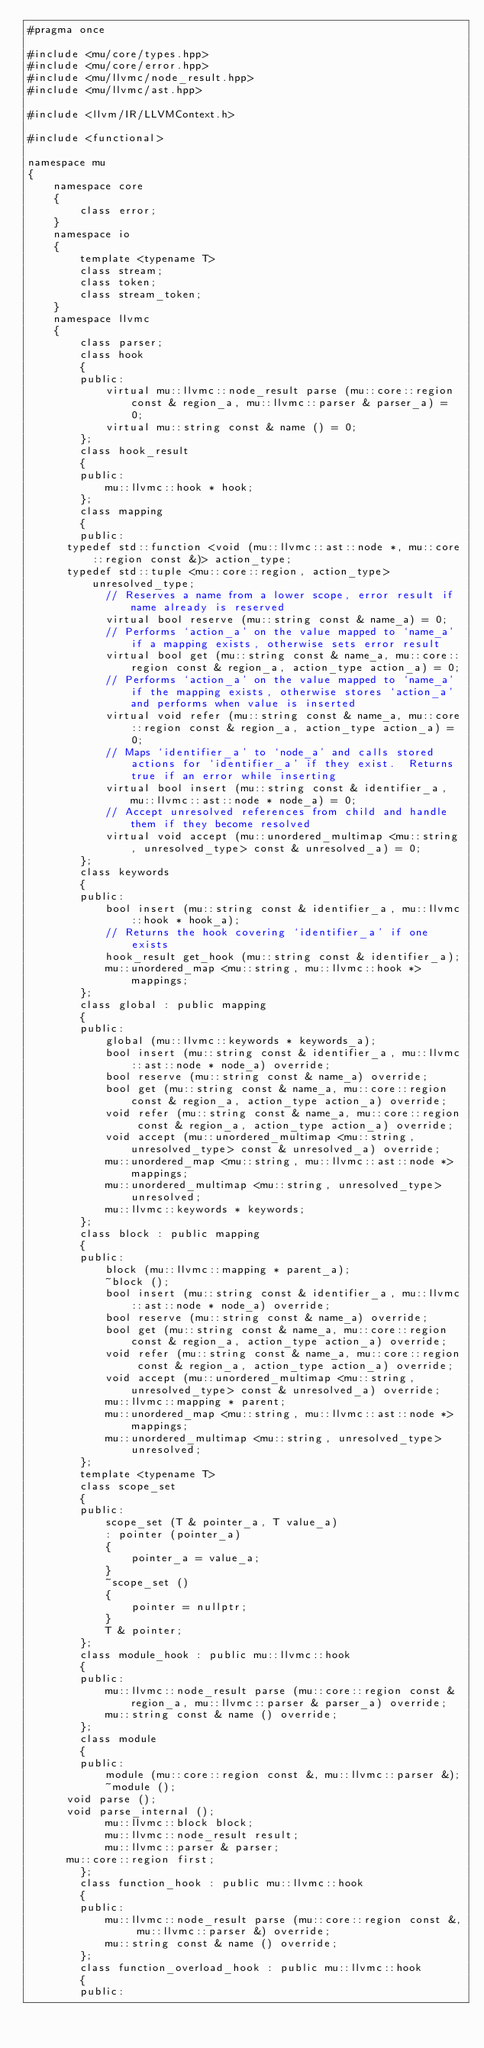Convert code to text. <code><loc_0><loc_0><loc_500><loc_500><_C++_>#pragma once

#include <mu/core/types.hpp>
#include <mu/core/error.hpp>
#include <mu/llvmc/node_result.hpp>
#include <mu/llvmc/ast.hpp>

#include <llvm/IR/LLVMContext.h>

#include <functional>

namespace mu
{
    namespace core
    {
        class error;
    }
    namespace io
    {
        template <typename T>
        class stream;
        class token;
        class stream_token;
    }
    namespace llvmc
    {
        class parser;
        class hook
        {
        public:
            virtual mu::llvmc::node_result parse (mu::core::region const & region_a, mu::llvmc::parser & parser_a) = 0;
            virtual mu::string const & name () = 0;
        };
        class hook_result
        {
        public:
            mu::llvmc::hook * hook;
        };
        class mapping
        {
        public:
			typedef std::function <void (mu::llvmc::ast::node *, mu::core::region const &)> action_type;
			typedef std::tuple <mu::core::region, action_type> unresolved_type;
            // Reserves a name from a lower scope, error result if name already is reserved
            virtual bool reserve (mu::string const & name_a) = 0;
            // Performs `action_a' on the value mapped to `name_a' if a mapping exists, otherwise sets error result
            virtual bool get (mu::string const & name_a, mu::core::region const & region_a, action_type action_a) = 0;
            // Performs `action_a' on the value mapped to `name_a' if the mapping exists, otherwise stores `action_a' and performs when value is inserted
            virtual void refer (mu::string const & name_a, mu::core::region const & region_a, action_type action_a) = 0;
            // Maps `identifier_a' to `node_a' and calls stored actions for `identifier_a' if they exist.  Returns true if an error while inserting
            virtual bool insert (mu::string const & identifier_a, mu::llvmc::ast::node * node_a) = 0;
            // Accept unresolved references from child and handle them if they become resolved
            virtual void accept (mu::unordered_multimap <mu::string, unresolved_type> const & unresolved_a) = 0;
        };
        class keywords
        {
        public:
            bool insert (mu::string const & identifier_a, mu::llvmc::hook * hook_a);
            // Returns the hook covering `identifier_a' if one exists
            hook_result get_hook (mu::string const & identifier_a);
            mu::unordered_map <mu::string, mu::llvmc::hook *> mappings;
        };
        class global : public mapping
        {
        public:
            global (mu::llvmc::keywords * keywords_a);
            bool insert (mu::string const & identifier_a, mu::llvmc::ast::node * node_a) override;
            bool reserve (mu::string const & name_a) override;
            bool get (mu::string const & name_a, mu::core::region const & region_a, action_type action_a) override;
            void refer (mu::string const & name_a, mu::core::region const & region_a, action_type action_a) override;
            void accept (mu::unordered_multimap <mu::string, unresolved_type> const & unresolved_a) override;
            mu::unordered_map <mu::string, mu::llvmc::ast::node *> mappings;
            mu::unordered_multimap <mu::string, unresolved_type> unresolved;
            mu::llvmc::keywords * keywords;
        };
        class block : public mapping
        {
        public:
            block (mu::llvmc::mapping * parent_a);
            ~block ();
            bool insert (mu::string const & identifier_a, mu::llvmc::ast::node * node_a) override;
            bool reserve (mu::string const & name_a) override;
            bool get (mu::string const & name_a, mu::core::region const & region_a, action_type action_a) override;
            void refer (mu::string const & name_a, mu::core::region const & region_a, action_type action_a) override;
            void accept (mu::unordered_multimap <mu::string, unresolved_type> const & unresolved_a) override;
            mu::llvmc::mapping * parent;
            mu::unordered_map <mu::string, mu::llvmc::ast::node *> mappings;
            mu::unordered_multimap <mu::string, unresolved_type> unresolved;
        };
        template <typename T>
        class scope_set
        {
        public:
            scope_set (T & pointer_a, T value_a)
            : pointer (pointer_a)
            {
                pointer_a = value_a;
            }
            ~scope_set ()
            {
                pointer = nullptr;
            }
            T & pointer;
        };
        class module_hook : public mu::llvmc::hook
        {
        public:
            mu::llvmc::node_result parse (mu::core::region const & region_a, mu::llvmc::parser & parser_a) override;
            mu::string const & name () override;
        };
        class module
        {
        public:
            module (mu::core::region const &, mu::llvmc::parser &);
            ~module ();
			void parse ();
			void parse_internal ();
            mu::llvmc::block block;
            mu::llvmc::node_result result;
            mu::llvmc::parser & parser;
			mu::core::region first;
        };
        class function_hook : public mu::llvmc::hook
        {
        public:
            mu::llvmc::node_result parse (mu::core::region const &, mu::llvmc::parser &) override;
            mu::string const & name () override;
        };
        class function_overload_hook : public mu::llvmc::hook
        {
        public:</code> 